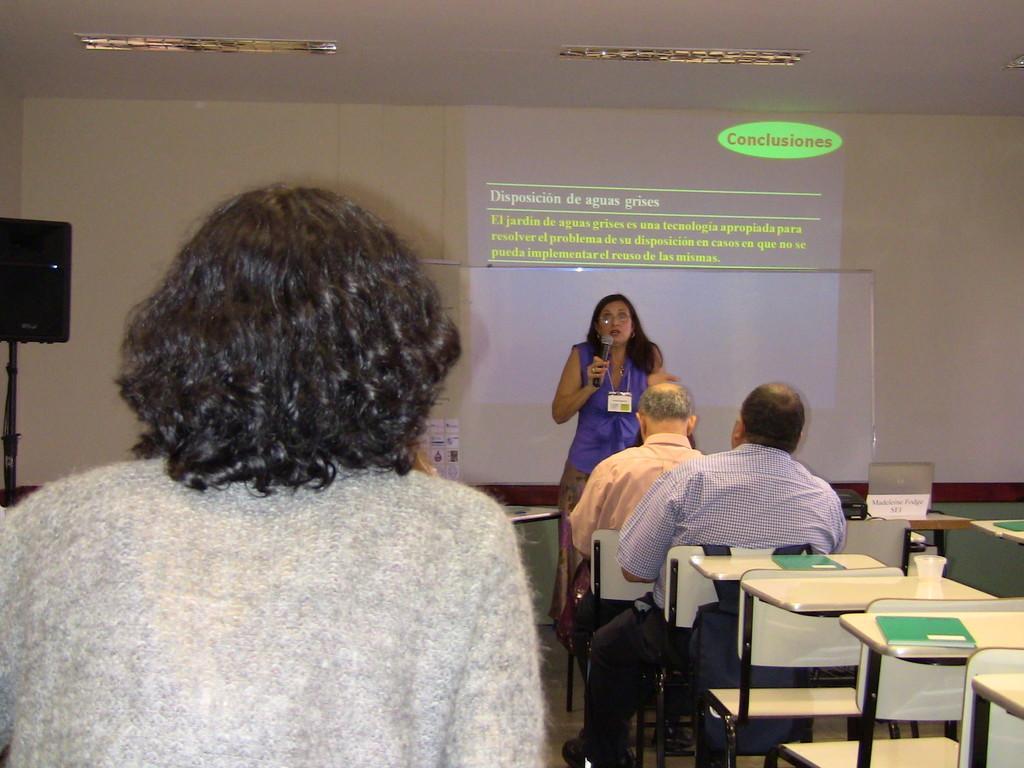Could you give a brief overview of what you see in this image? In this image I can see few people are sitting on chairs and a woman is standing. I can also see she is holding a mic. In the background I can see a projector screen on wall. 